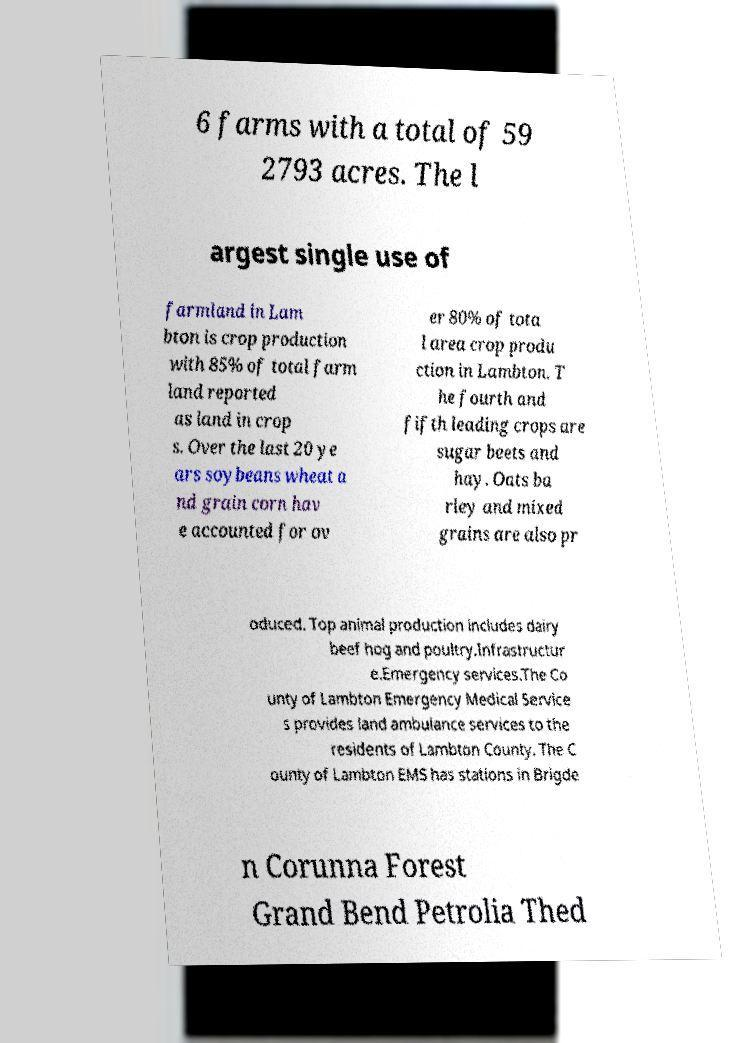Please read and relay the text visible in this image. What does it say? 6 farms with a total of 59 2793 acres. The l argest single use of farmland in Lam bton is crop production with 85% of total farm land reported as land in crop s. Over the last 20 ye ars soybeans wheat a nd grain corn hav e accounted for ov er 80% of tota l area crop produ ction in Lambton. T he fourth and fifth leading crops are sugar beets and hay. Oats ba rley and mixed grains are also pr oduced. Top animal production includes dairy beef hog and poultry.Infrastructur e.Emergency services.The Co unty of Lambton Emergency Medical Service s provides land ambulance services to the residents of Lambton County. The C ounty of Lambton EMS has stations in Brigde n Corunna Forest Grand Bend Petrolia Thed 